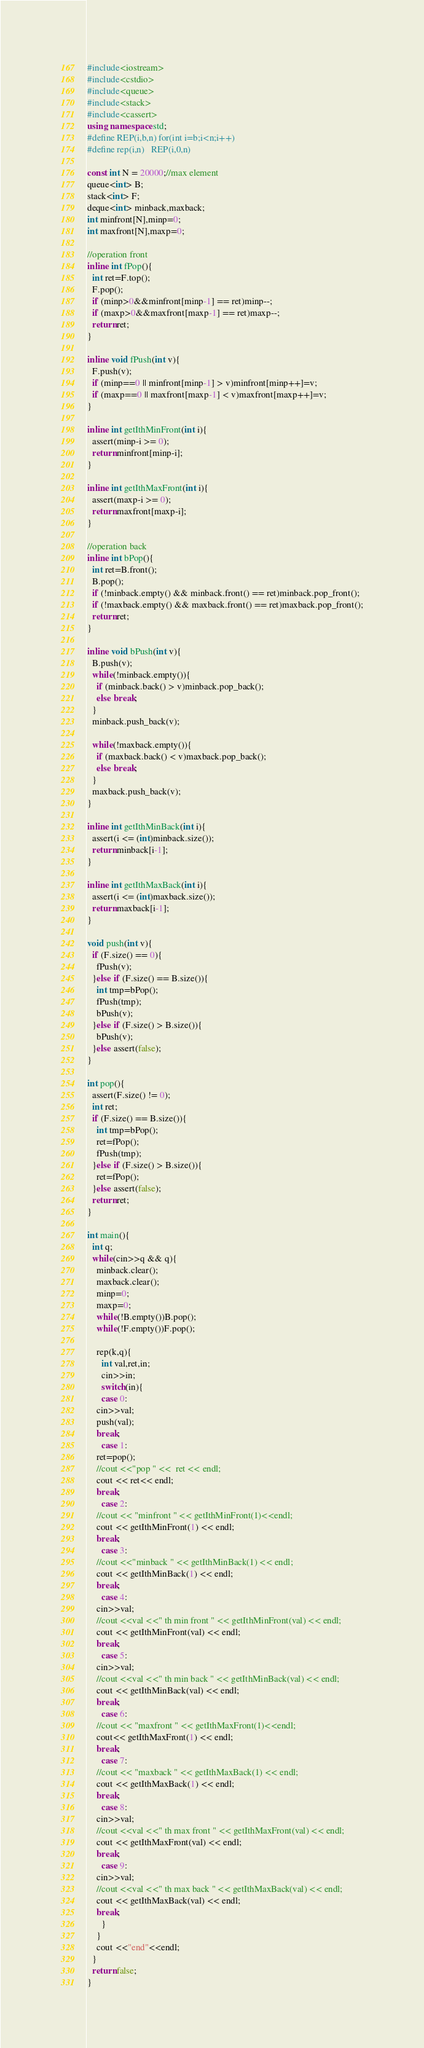<code> <loc_0><loc_0><loc_500><loc_500><_C++_>#include<iostream>
#include<cstdio>
#include<queue>
#include<stack>
#include<cassert>
using namespace std;
#define REP(i,b,n) for(int i=b;i<n;i++)
#define rep(i,n)   REP(i,0,n)

const int N = 20000;//max element
queue<int> B;
stack<int> F;
deque<int> minback,maxback;
int minfront[N],minp=0;
int maxfront[N],maxp=0;

//operation front
inline int fPop(){
  int ret=F.top();
  F.pop();
  if (minp>0&&minfront[minp-1] == ret)minp--;
  if (maxp>0&&maxfront[maxp-1] == ret)maxp--;
  return ret;
}

inline void fPush(int v){
  F.push(v);
  if (minp==0 || minfront[minp-1] > v)minfront[minp++]=v;
  if (maxp==0 || maxfront[maxp-1] < v)maxfront[maxp++]=v;
}

inline int getIthMinFront(int i){
  assert(minp-i >= 0);
  return minfront[minp-i];
}

inline int getIthMaxFront(int i){
  assert(maxp-i >= 0);
  return maxfront[maxp-i];
}

//operation back
inline int bPop(){
  int ret=B.front();
  B.pop();
  if (!minback.empty() && minback.front() == ret)minback.pop_front();
  if (!maxback.empty() && maxback.front() == ret)maxback.pop_front();
  return ret;
}

inline void bPush(int v){
  B.push(v);
  while(!minback.empty()){
    if (minback.back() > v)minback.pop_back();
    else break;
  }
  minback.push_back(v);

  while(!maxback.empty()){
    if (maxback.back() < v)maxback.pop_back();
    else break;
  }
  maxback.push_back(v);
}

inline int getIthMinBack(int i){
  assert(i <= (int)minback.size());
  return minback[i-1];
}

inline int getIthMaxBack(int i){
  assert(i <= (int)maxback.size());
  return maxback[i-1];
}

void push(int v){
  if (F.size() == 0){
    fPush(v);
  }else if (F.size() == B.size()){
    int tmp=bPop();
    fPush(tmp);
    bPush(v);
  }else if (F.size() > B.size()){
    bPush(v);
  }else assert(false);
}

int pop(){
  assert(F.size() != 0);
  int ret;
  if (F.size() == B.size()){
    int tmp=bPop();
    ret=fPop();
    fPush(tmp);
  }else if (F.size() > B.size()){
    ret=fPop();
  }else assert(false);
  return ret;
}

int main(){
  int q;
  while(cin>>q && q){
    minback.clear();
    maxback.clear();
    minp=0;
    maxp=0;
    while(!B.empty())B.pop();
    while(!F.empty())F.pop();

    rep(k,q){
      int val,ret,in;
      cin>>in;
      switch(in){
      case 0:
	cin>>val;
	push(val);
	break;
      case 1:
	ret=pop();
	//cout <<"pop " <<  ret << endl;
	cout << ret<< endl;
	break;
      case 2:
	//cout << "minfront " << getIthMinFront(1)<<endl;
	cout << getIthMinFront(1) << endl;
	break;
      case 3:
	//cout <<"minback " << getIthMinBack(1) << endl;
	cout << getIthMinBack(1) << endl;
	break;
      case 4:
	cin>>val;
	//cout <<val <<" th min front " << getIthMinFront(val) << endl;
	cout << getIthMinFront(val) << endl;
	break;
      case 5:
	cin>>val;
	//cout <<val <<" th min back " << getIthMinBack(val) << endl;
	cout << getIthMinBack(val) << endl;
	break;
      case 6:
	//cout << "maxfront " << getIthMaxFront(1)<<endl;
	cout<< getIthMaxFront(1) << endl;
	break;
      case 7:
	//cout << "maxback " << getIthMaxBack(1) << endl;
	cout << getIthMaxBack(1) << endl;
	break;
      case 8:
	cin>>val;
	//cout <<val <<" th max front " << getIthMaxFront(val) << endl;
	cout << getIthMaxFront(val) << endl;
	break;
      case 9:
	cin>>val;
	//cout <<val <<" th max back " << getIthMaxBack(val) << endl;
	cout << getIthMaxBack(val) << endl;
	break;
      }
    }
    cout <<"end"<<endl;
  }
  return false;
}</code> 